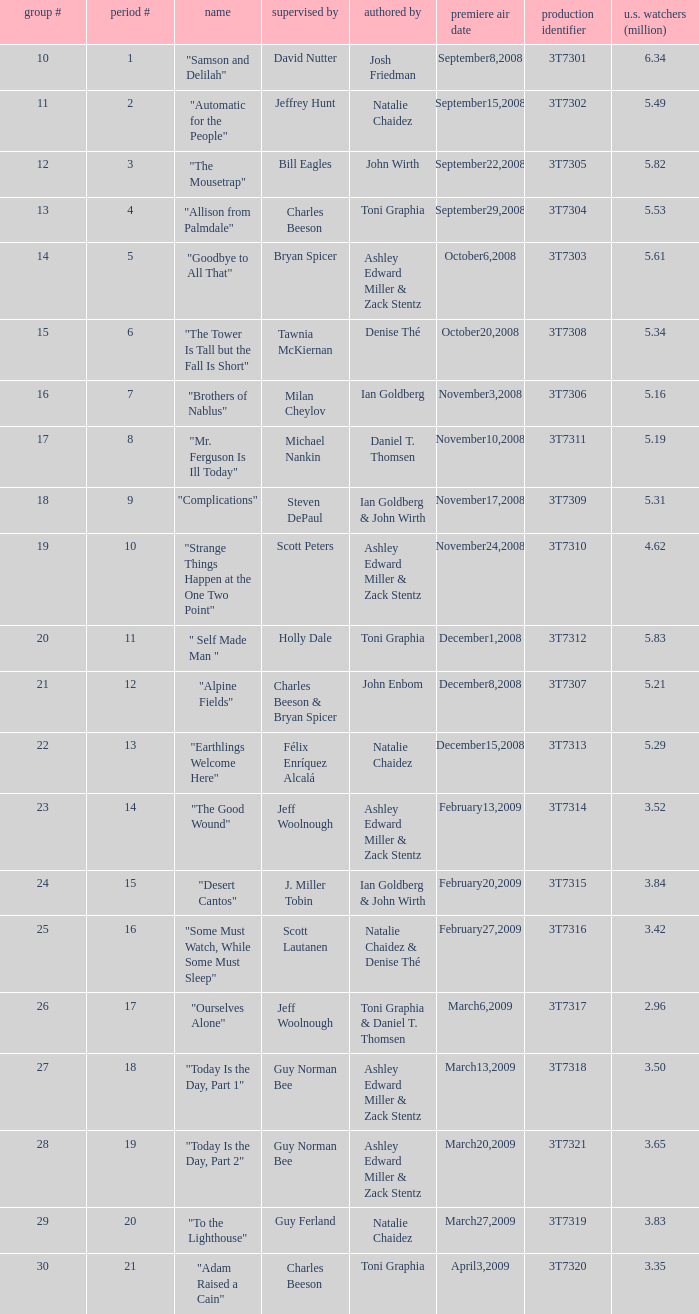Which episode number was directed by Bill Eagles? 12.0. 